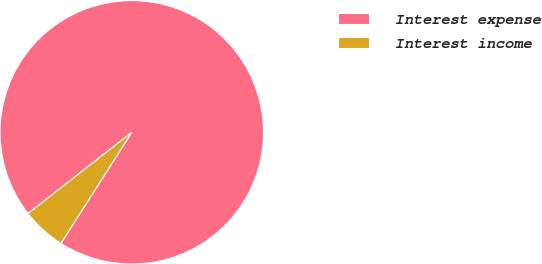Convert chart to OTSL. <chart><loc_0><loc_0><loc_500><loc_500><pie_chart><fcel>Interest expense<fcel>Interest income<nl><fcel>94.61%<fcel>5.39%<nl></chart> 